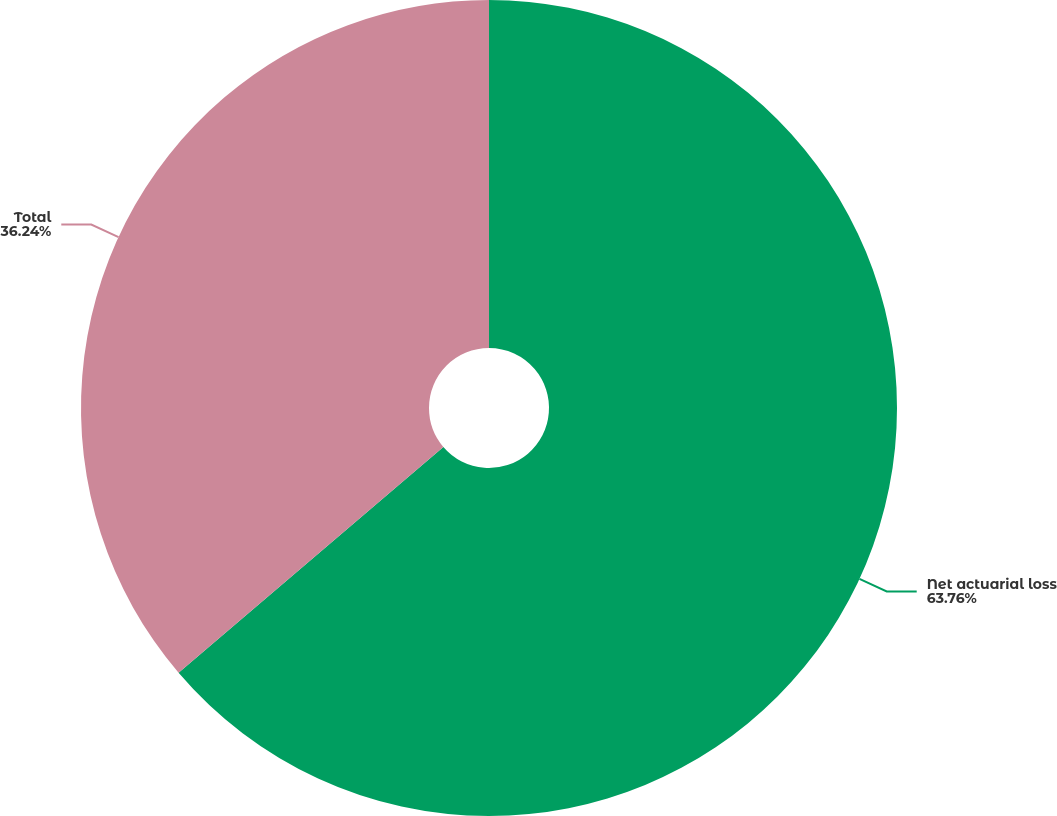Convert chart to OTSL. <chart><loc_0><loc_0><loc_500><loc_500><pie_chart><fcel>Net actuarial loss<fcel>Total<nl><fcel>63.76%<fcel>36.24%<nl></chart> 